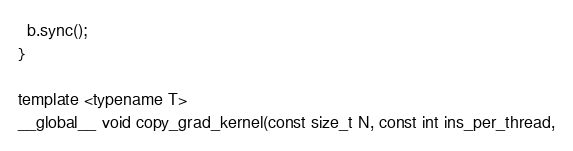<code> <loc_0><loc_0><loc_500><loc_500><_Cuda_>  b.sync();
}

template <typename T>
__global__ void copy_grad_kernel(const size_t N, const int ins_per_thread,</code> 